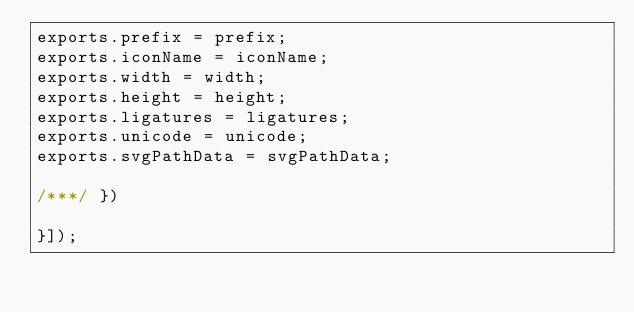<code> <loc_0><loc_0><loc_500><loc_500><_JavaScript_>exports.prefix = prefix;
exports.iconName = iconName;
exports.width = width;
exports.height = height;
exports.ligatures = ligatures;
exports.unicode = unicode;
exports.svgPathData = svgPathData;

/***/ })

}]);</code> 